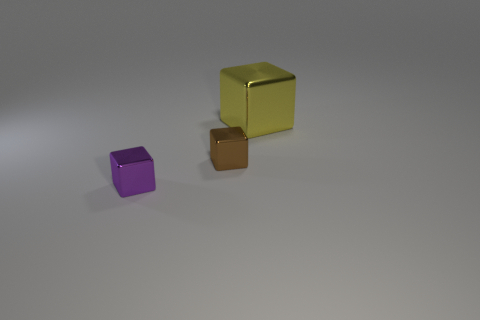Is there any other thing that has the same size as the yellow thing?
Offer a very short reply. No. There is a tiny purple thing that is the same shape as the big object; what material is it?
Your response must be concise. Metal. There is a yellow shiny block; are there any purple shiny blocks behind it?
Provide a succinct answer. No. Do the small thing that is on the right side of the small purple cube and the big yellow block have the same material?
Provide a short and direct response. Yes. Are there any big metal things that have the same color as the big cube?
Offer a very short reply. No. The big metal object has what shape?
Your answer should be compact. Cube. There is a small object to the right of the small thing that is on the left side of the brown thing; what color is it?
Ensure brevity in your answer.  Brown. There is a block that is in front of the small brown metallic cube; how big is it?
Your response must be concise. Small. Is there another block made of the same material as the tiny purple block?
Keep it short and to the point. Yes. What number of large purple objects are the same shape as the small purple metal object?
Keep it short and to the point. 0. 